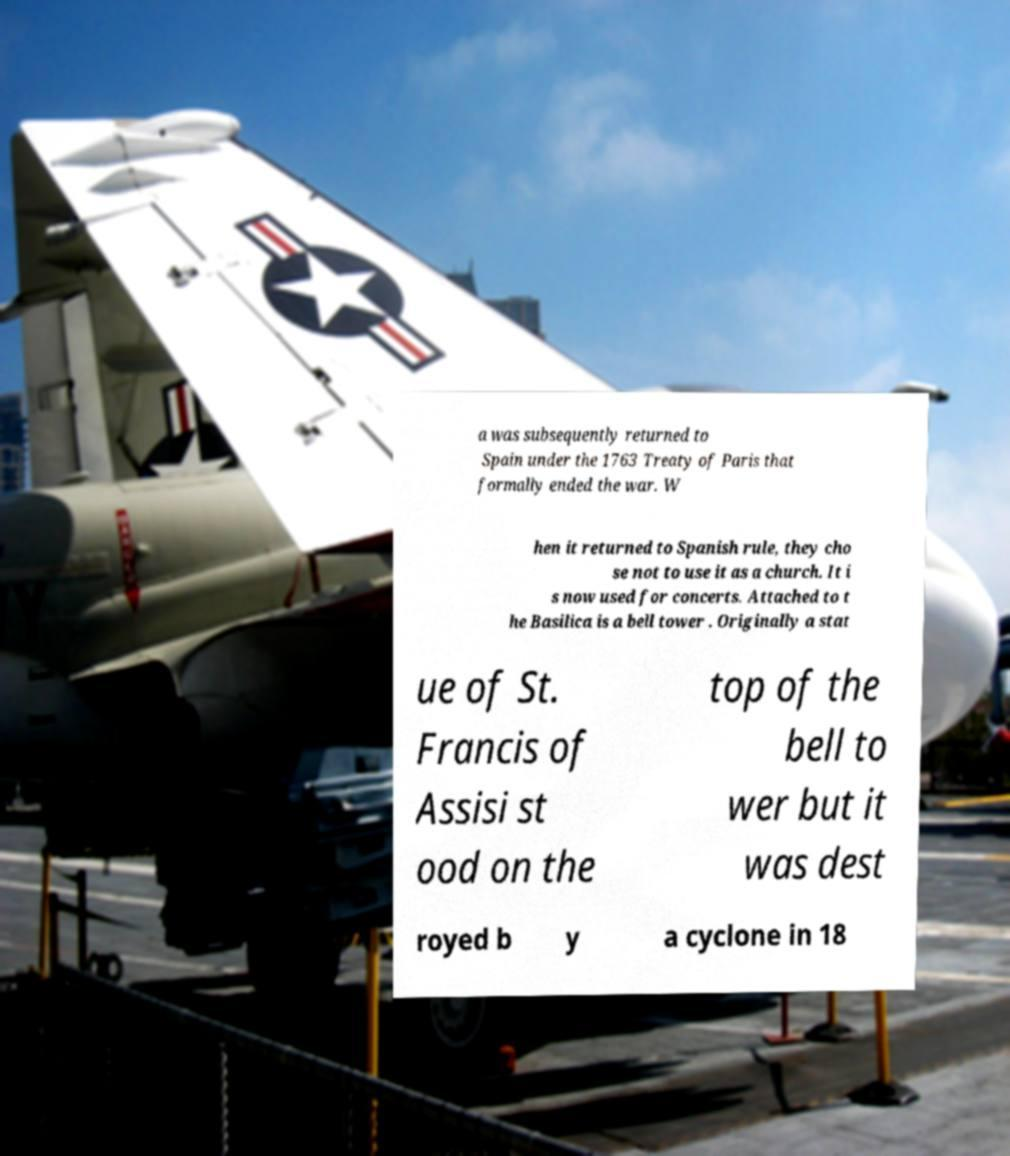I need the written content from this picture converted into text. Can you do that? a was subsequently returned to Spain under the 1763 Treaty of Paris that formally ended the war. W hen it returned to Spanish rule, they cho se not to use it as a church. It i s now used for concerts. Attached to t he Basilica is a bell tower . Originally a stat ue of St. Francis of Assisi st ood on the top of the bell to wer but it was dest royed b y a cyclone in 18 